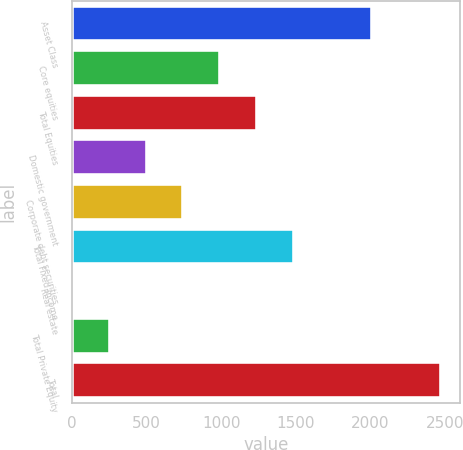Convert chart to OTSL. <chart><loc_0><loc_0><loc_500><loc_500><bar_chart><fcel>Asset Class<fcel>Core equities<fcel>Total Equities<fcel>Domestic government<fcel>Corporate debt securities<fcel>Total Fixed Income<fcel>Real estate<fcel>Total Private Equity<fcel>Total<nl><fcel>2015<fcel>993.8<fcel>1241<fcel>499.4<fcel>746.6<fcel>1488.2<fcel>5<fcel>252.2<fcel>2477<nl></chart> 